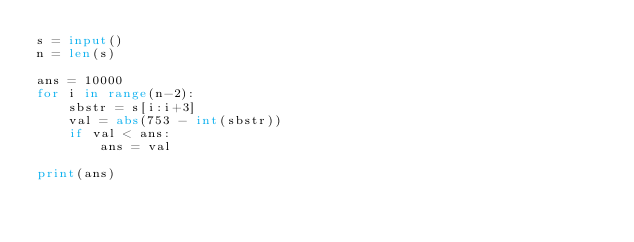<code> <loc_0><loc_0><loc_500><loc_500><_Python_>s = input()
n = len(s)

ans = 10000
for i in range(n-2):
    sbstr = s[i:i+3]
    val = abs(753 - int(sbstr))
    if val < ans:
        ans = val

print(ans)</code> 